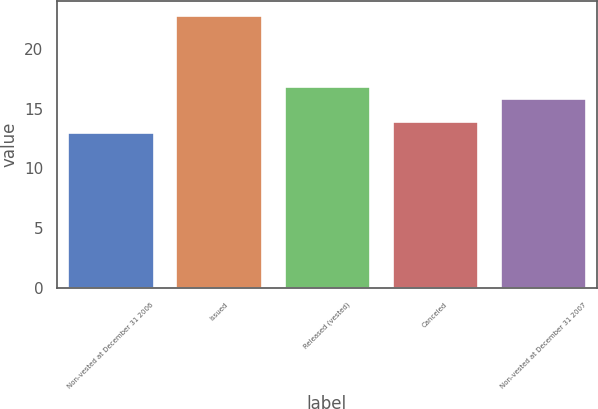Convert chart. <chart><loc_0><loc_0><loc_500><loc_500><bar_chart><fcel>Non-vested at December 31 2006<fcel>Issued<fcel>Released (vested)<fcel>Canceled<fcel>Non-vested at December 31 2007<nl><fcel>13.01<fcel>22.85<fcel>16.89<fcel>13.99<fcel>15.91<nl></chart> 